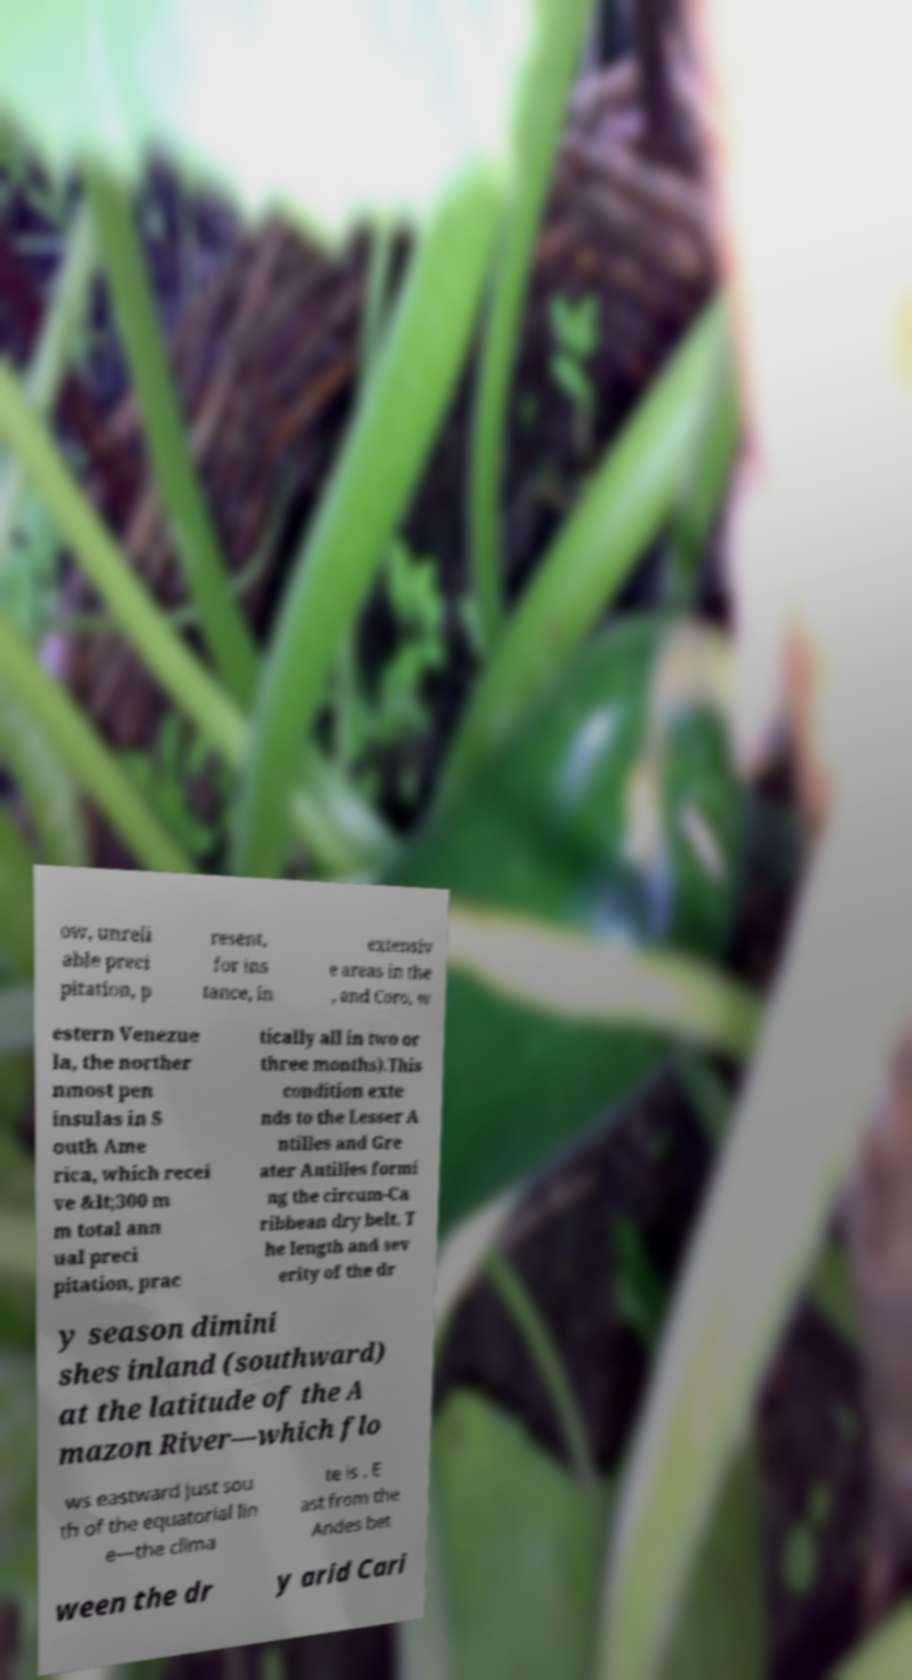Please read and relay the text visible in this image. What does it say? ow, unreli able preci pitation, p resent, for ins tance, in extensiv e areas in the , and Coro, w estern Venezue la, the norther nmost pen insulas in S outh Ame rica, which recei ve &lt;300 m m total ann ual preci pitation, prac tically all in two or three months).This condition exte nds to the Lesser A ntilles and Gre ater Antilles formi ng the circum-Ca ribbean dry belt. T he length and sev erity of the dr y season dimini shes inland (southward) at the latitude of the A mazon River—which flo ws eastward just sou th of the equatorial lin e—the clima te is . E ast from the Andes bet ween the dr y arid Cari 